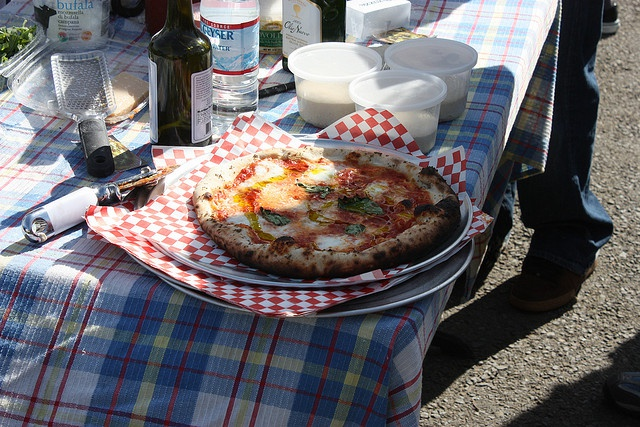Describe the objects in this image and their specific colors. I can see dining table in darkblue, black, white, gray, and darkgray tones, pizza in darkblue, black, maroon, and gray tones, people in darkblue, black, and gray tones, bottle in darkblue, black, darkgray, and gray tones, and bottle in darkblue, lightgray, darkgray, and gray tones in this image. 